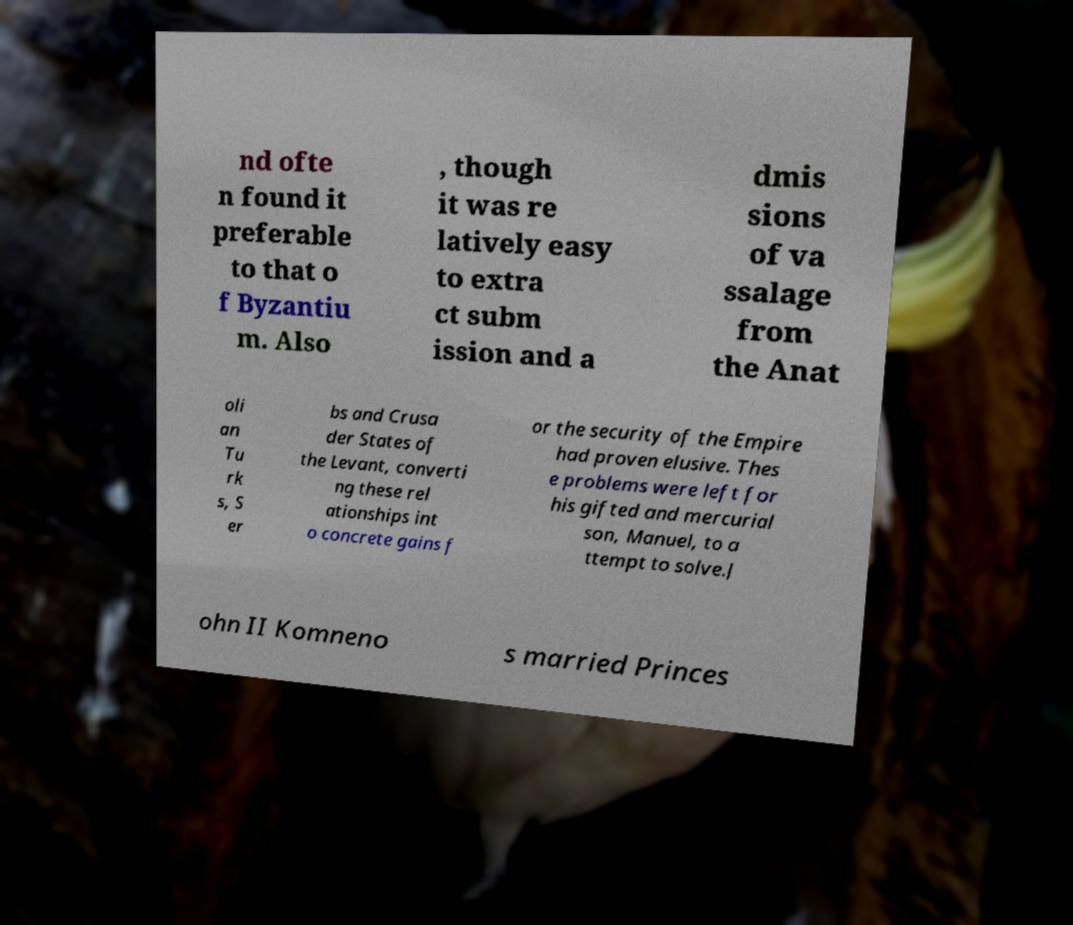Could you extract and type out the text from this image? nd ofte n found it preferable to that o f Byzantiu m. Also , though it was re latively easy to extra ct subm ission and a dmis sions of va ssalage from the Anat oli an Tu rk s, S er bs and Crusa der States of the Levant, converti ng these rel ationships int o concrete gains f or the security of the Empire had proven elusive. Thes e problems were left for his gifted and mercurial son, Manuel, to a ttempt to solve.J ohn II Komneno s married Princes 